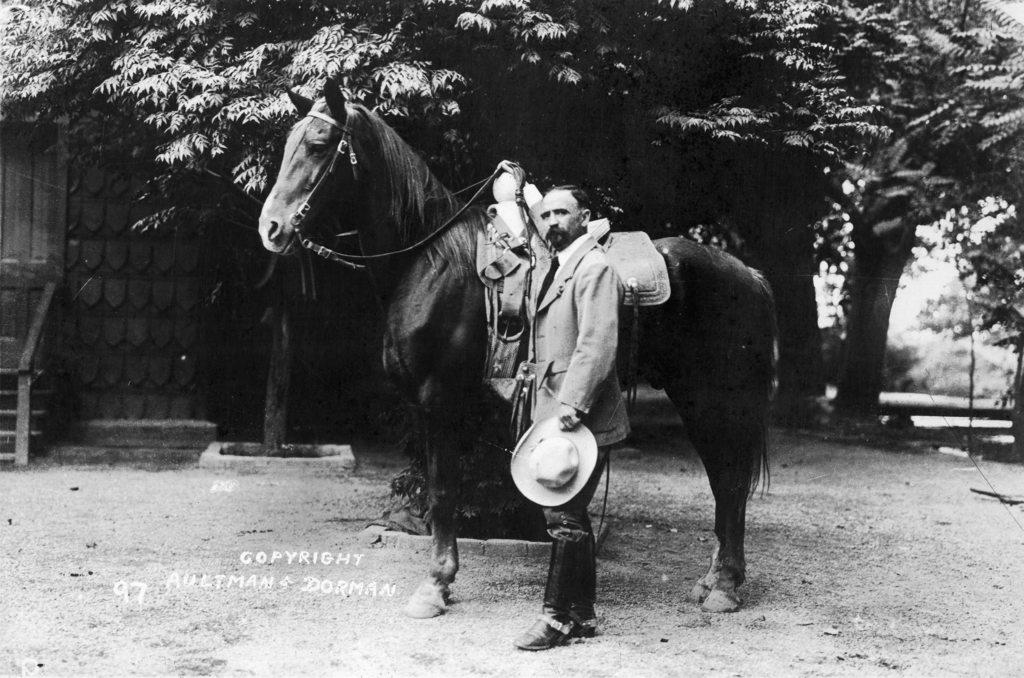What is the color scheme of the image? The image is black and white. Who or what can be seen in the image? There is a man in the image. What is the man doing in the image? The man is standing beside a horse. What can be seen in the background of the image? There are trees in the background of the image. How many planes can be seen in the image? There are no planes present in the image. What type of property does the man own in the image? There is no information about the man owning any property in the image. 